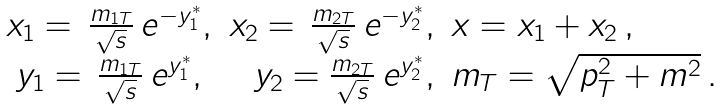<formula> <loc_0><loc_0><loc_500><loc_500>\begin{array} { c r l } x _ { 1 } = \, \frac { m _ { 1 T } } { \sqrt { s } } \, e ^ { - y ^ { * } _ { 1 } } , & x _ { 2 } = \, \frac { m _ { 2 T } } { \sqrt { s } } \, e ^ { - y ^ { * } _ { 2 } } , & x = x _ { 1 } + x _ { 2 } \, , \\ y _ { 1 } = \, \frac { m _ { 1 T } } { \sqrt { s } } \, e ^ { y ^ { * } _ { 1 } } , & y _ { 2 } = \frac { m _ { 2 T } } { \sqrt { s } } \, e ^ { y ^ { * } _ { 2 } } , & m _ { T } = \sqrt { p ^ { 2 } _ { T } + m ^ { 2 } } \, . \end{array}</formula> 